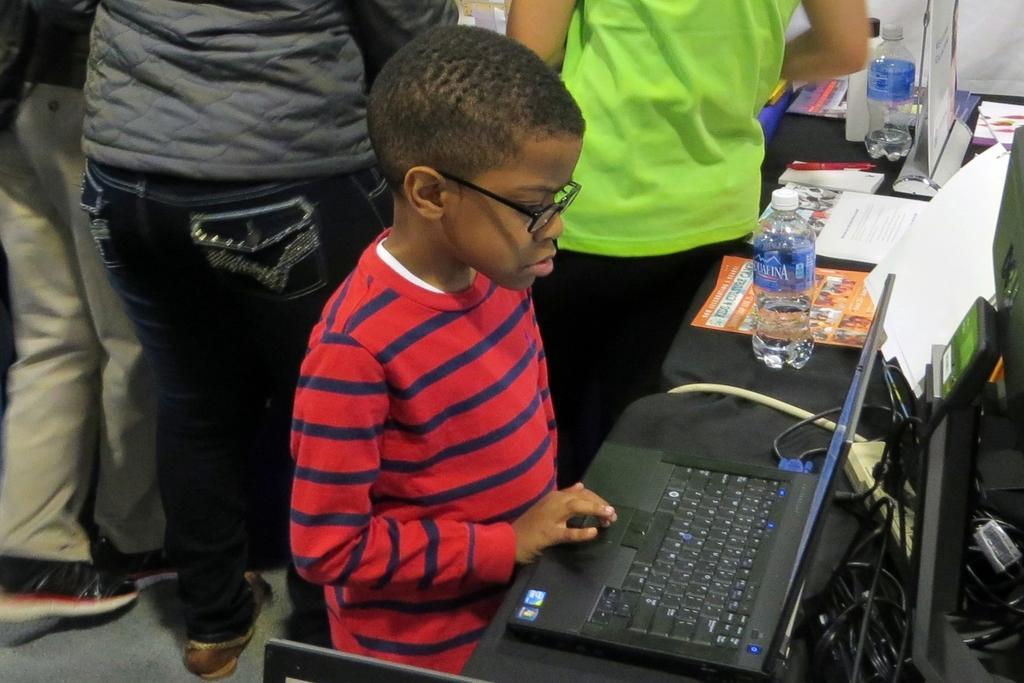Please provide a concise description of this image. In this picture I can see a boy using the laptop in the middle. On the right side there are water bottles, in the background there are few persons. 